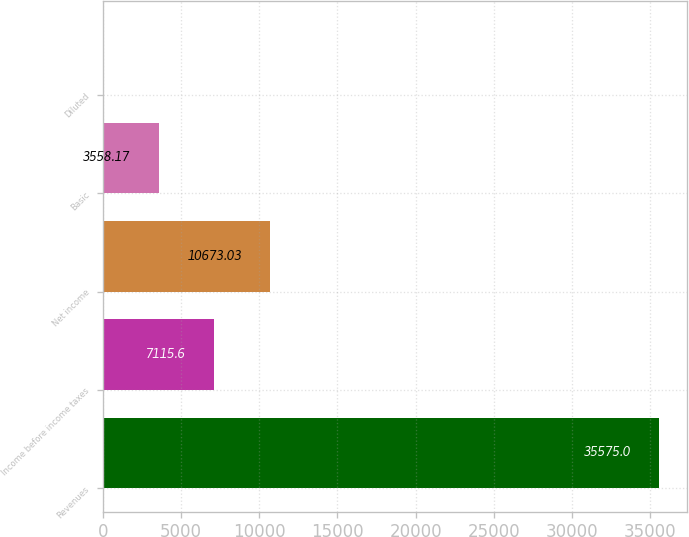Convert chart. <chart><loc_0><loc_0><loc_500><loc_500><bar_chart><fcel>Revenues<fcel>Income before income taxes<fcel>Net income<fcel>Basic<fcel>Diluted<nl><fcel>35575<fcel>7115.6<fcel>10673<fcel>3558.17<fcel>0.74<nl></chart> 